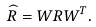<formula> <loc_0><loc_0><loc_500><loc_500>\widehat { R } = W R W ^ { T } .</formula> 